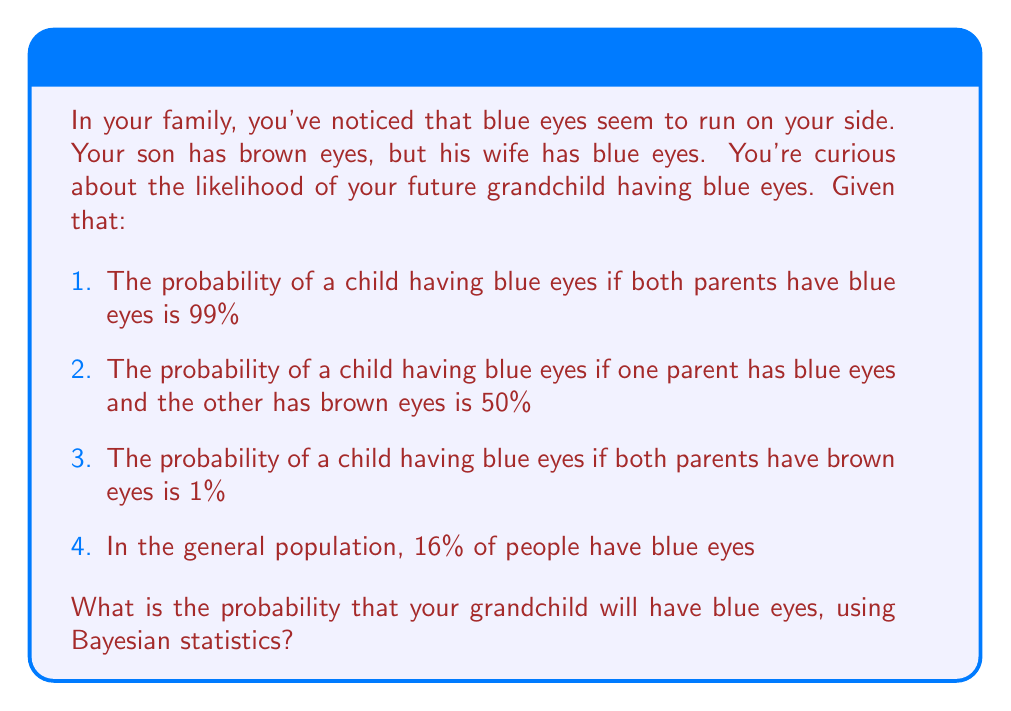What is the answer to this math problem? To solve this problem, we'll use Bayes' theorem, which is given by:

$$P(A|B) = \frac{P(B|A) \cdot P(A)}{P(B)}$$

Where:
$A$ is the event that the grandchild has blue eyes
$B$ is the event that one parent (your daughter-in-law) has blue eyes and the other (your son) has brown eyes

We know:
$P(B|A) = 0.50$ (probability of parents' eye colors given the child has blue eyes)
$P(A) = 0.16$ (probability of blue eyes in the general population)

We need to calculate $P(B)$:
$P(B) = P(B|A) \cdot P(A) + P(B|\text{not }A) \cdot P(\text{not }A)$
$= 0.50 \cdot 0.16 + 0.50 \cdot 0.84 = 0.08 + 0.42 = 0.50$

Now we can apply Bayes' theorem:

$$P(A|B) = \frac{0.50 \cdot 0.16}{0.50} = 0.16$$

Therefore, the probability that your grandchild will have blue eyes is 0.16 or 16%.
Answer: 16% 